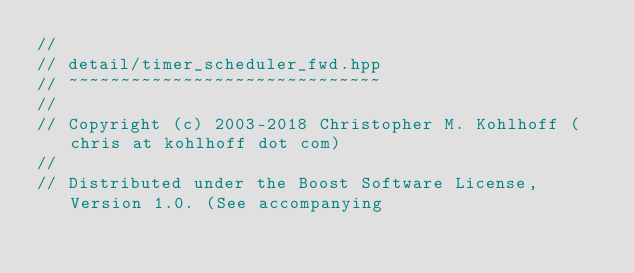Convert code to text. <code><loc_0><loc_0><loc_500><loc_500><_C++_>//
// detail/timer_scheduler_fwd.hpp
// ~~~~~~~~~~~~~~~~~~~~~~~~~~~~~~
//
// Copyright (c) 2003-2018 Christopher M. Kohlhoff (chris at kohlhoff dot com)
//
// Distributed under the Boost Software License, Version 1.0. (See accompanying</code> 